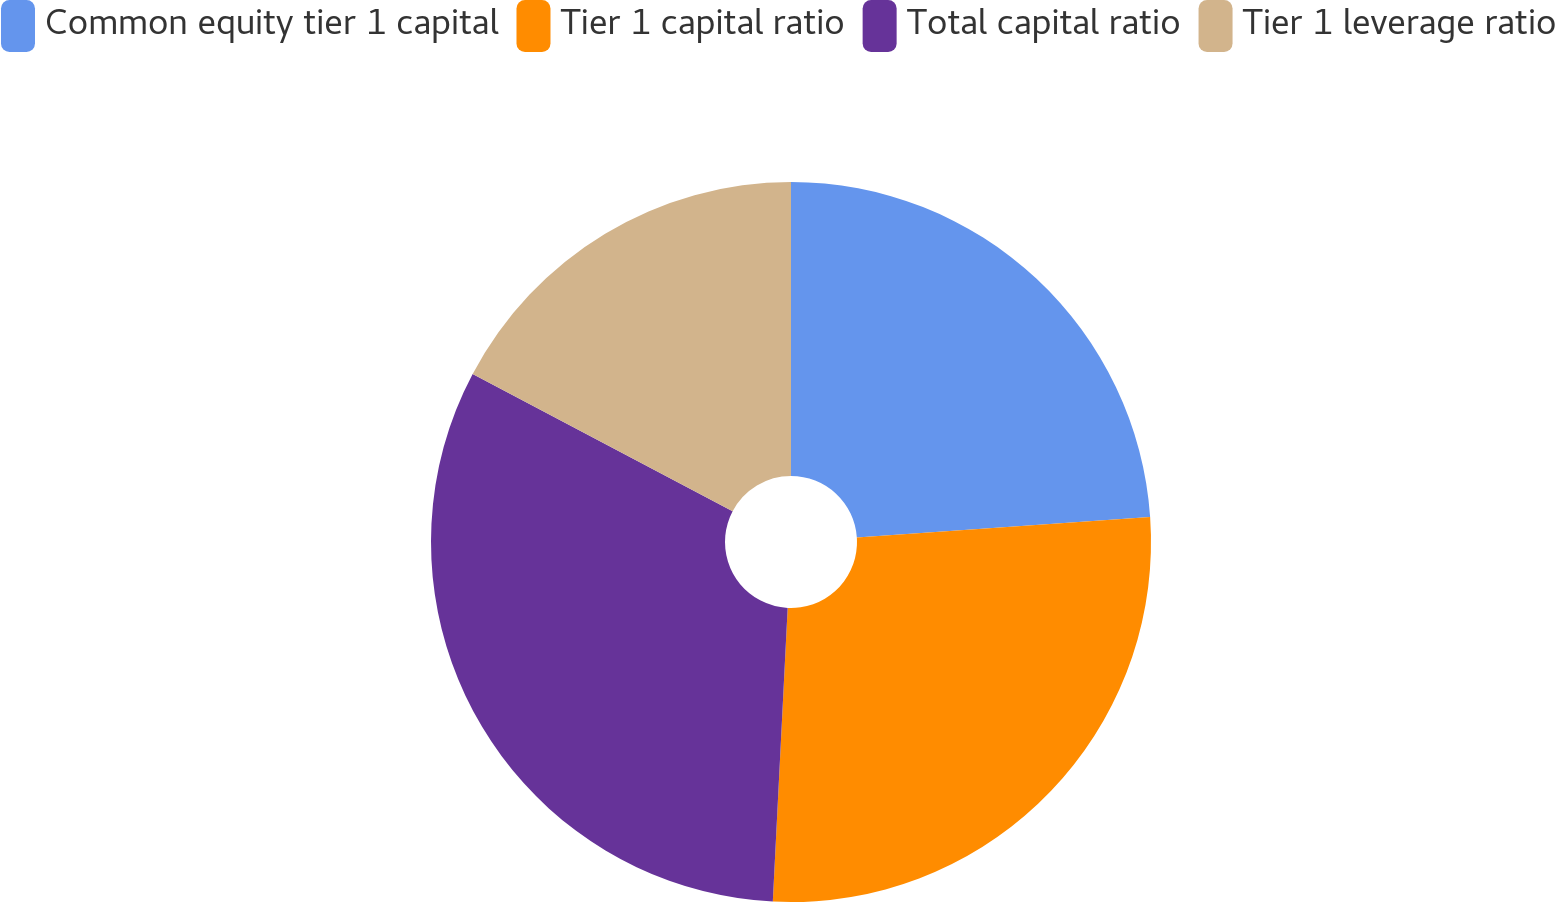<chart> <loc_0><loc_0><loc_500><loc_500><pie_chart><fcel>Common equity tier 1 capital<fcel>Tier 1 capital ratio<fcel>Total capital ratio<fcel>Tier 1 leverage ratio<nl><fcel>23.9%<fcel>26.91%<fcel>31.93%<fcel>17.27%<nl></chart> 